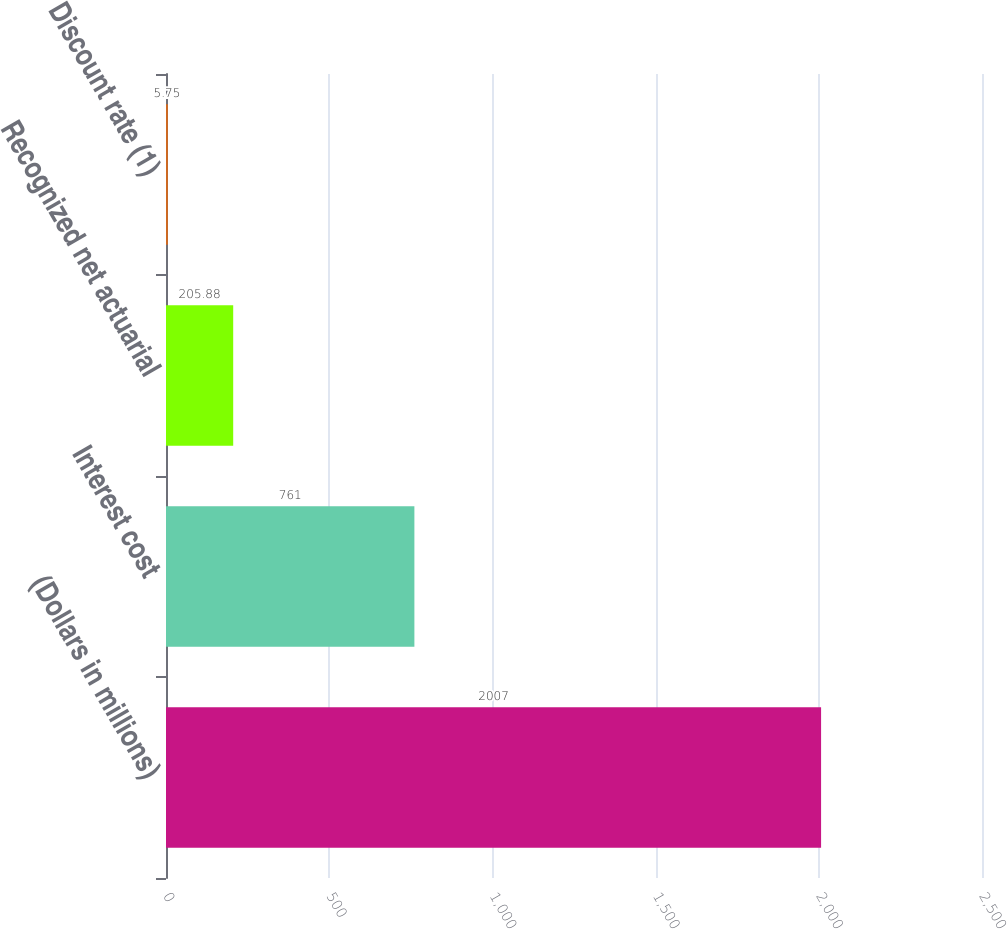Convert chart to OTSL. <chart><loc_0><loc_0><loc_500><loc_500><bar_chart><fcel>(Dollars in millions)<fcel>Interest cost<fcel>Recognized net actuarial<fcel>Discount rate (1)<nl><fcel>2007<fcel>761<fcel>205.88<fcel>5.75<nl></chart> 